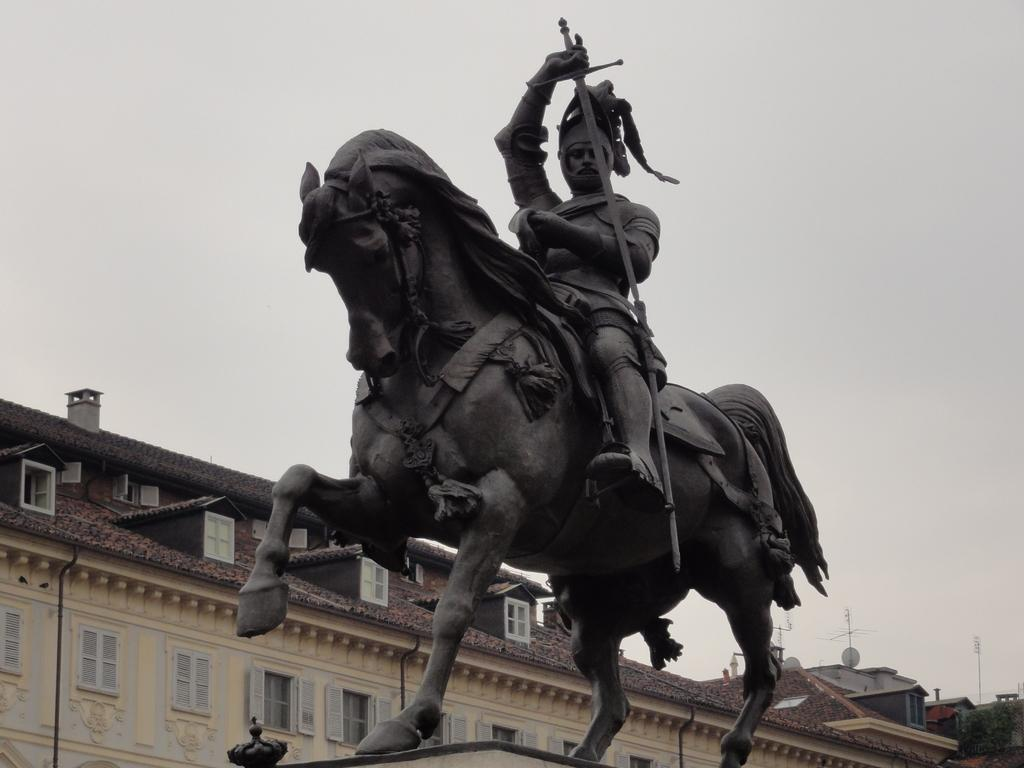What can be seen at the top of the image? The sky is visible towards the top of the image. What is located towards the bottom of the image? There are houses towards the bottom of the image. What feature is present in the houses? There are windows in the image. What is the profession of the person in the image? There is a sculptor in the image. What type of shirt is the farmer wearing in the image? There is no farmer present in the image, so it is not possible to answer that question. 